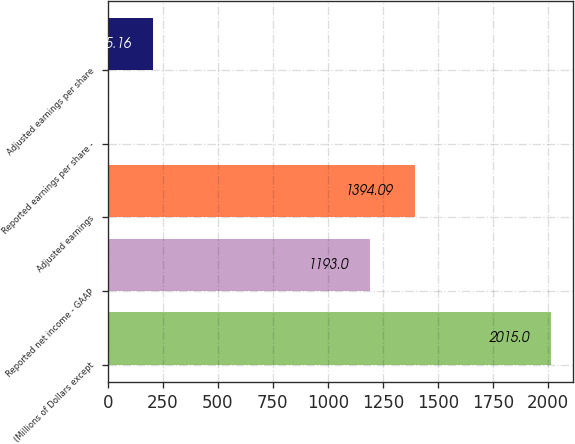Convert chart. <chart><loc_0><loc_0><loc_500><loc_500><bar_chart><fcel>(Millions of Dollars except<fcel>Reported net income - GAAP<fcel>Adjusted earnings<fcel>Reported earnings per share -<fcel>Adjusted earnings per share<nl><fcel>2015<fcel>1193<fcel>1394.09<fcel>4.07<fcel>205.16<nl></chart> 